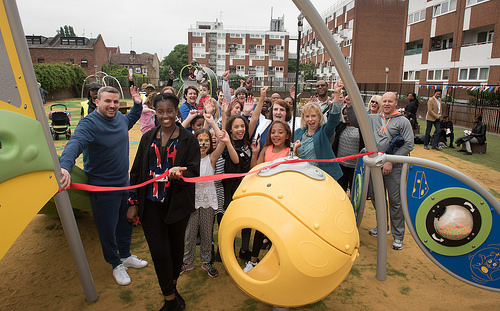<image>
Can you confirm if the ribbon is to the left of the woman? No. The ribbon is not to the left of the woman. From this viewpoint, they have a different horizontal relationship. 